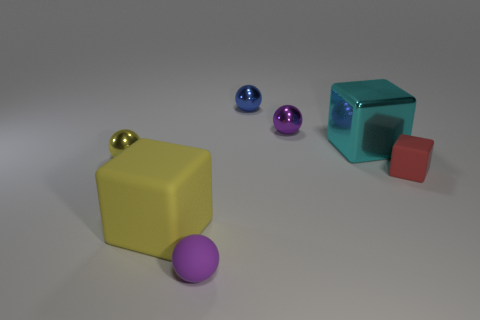Is the color of the big matte cube the same as the big metal cube?
Offer a terse response. No. How many big things are to the right of the ball in front of the matte block left of the tiny purple metallic ball?
Your answer should be compact. 1. There is a yellow object that is the same material as the big cyan block; what shape is it?
Your answer should be compact. Sphere. What is the material of the block that is on the left side of the purple sphere that is behind the rubber cube that is to the right of the blue metallic sphere?
Your answer should be very brief. Rubber. How many objects are cubes that are on the right side of the purple matte ball or blue shiny spheres?
Offer a very short reply. 3. What number of other objects are there of the same shape as the yellow metal object?
Keep it short and to the point. 3. Are there more cyan metal objects to the left of the big rubber object than blue shiny spheres?
Provide a succinct answer. No. The purple metal object that is the same shape as the small yellow thing is what size?
Offer a very short reply. Small. Are there any other things that have the same material as the red object?
Provide a short and direct response. Yes. The large shiny thing is what shape?
Ensure brevity in your answer.  Cube. 